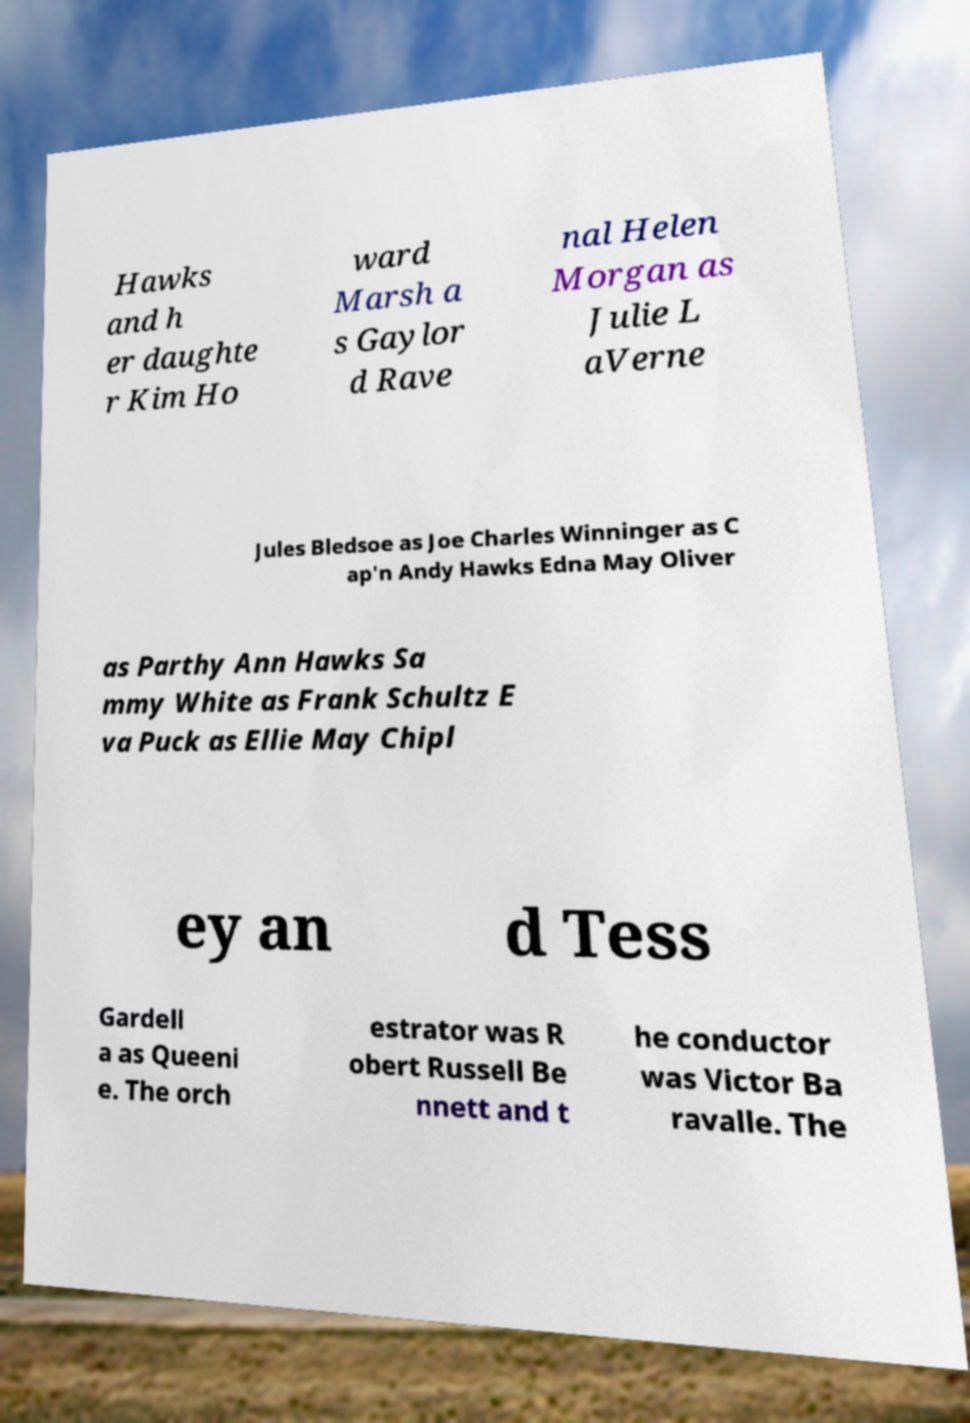Please read and relay the text visible in this image. What does it say? Hawks and h er daughte r Kim Ho ward Marsh a s Gaylor d Rave nal Helen Morgan as Julie L aVerne Jules Bledsoe as Joe Charles Winninger as C ap'n Andy Hawks Edna May Oliver as Parthy Ann Hawks Sa mmy White as Frank Schultz E va Puck as Ellie May Chipl ey an d Tess Gardell a as Queeni e. The orch estrator was R obert Russell Be nnett and t he conductor was Victor Ba ravalle. The 